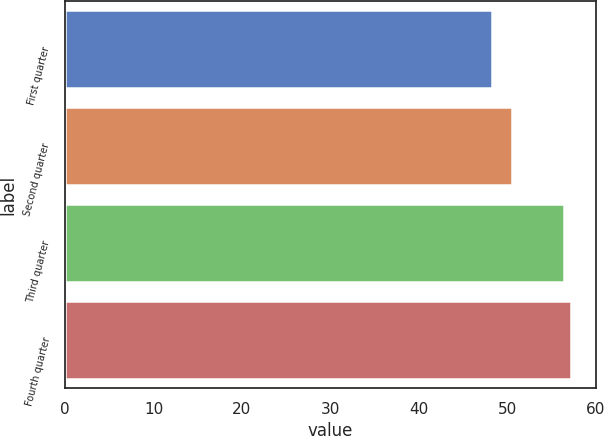Convert chart. <chart><loc_0><loc_0><loc_500><loc_500><bar_chart><fcel>First quarter<fcel>Second quarter<fcel>Third quarter<fcel>Fourth quarter<nl><fcel>48.31<fcel>50.54<fcel>56.4<fcel>57.21<nl></chart> 